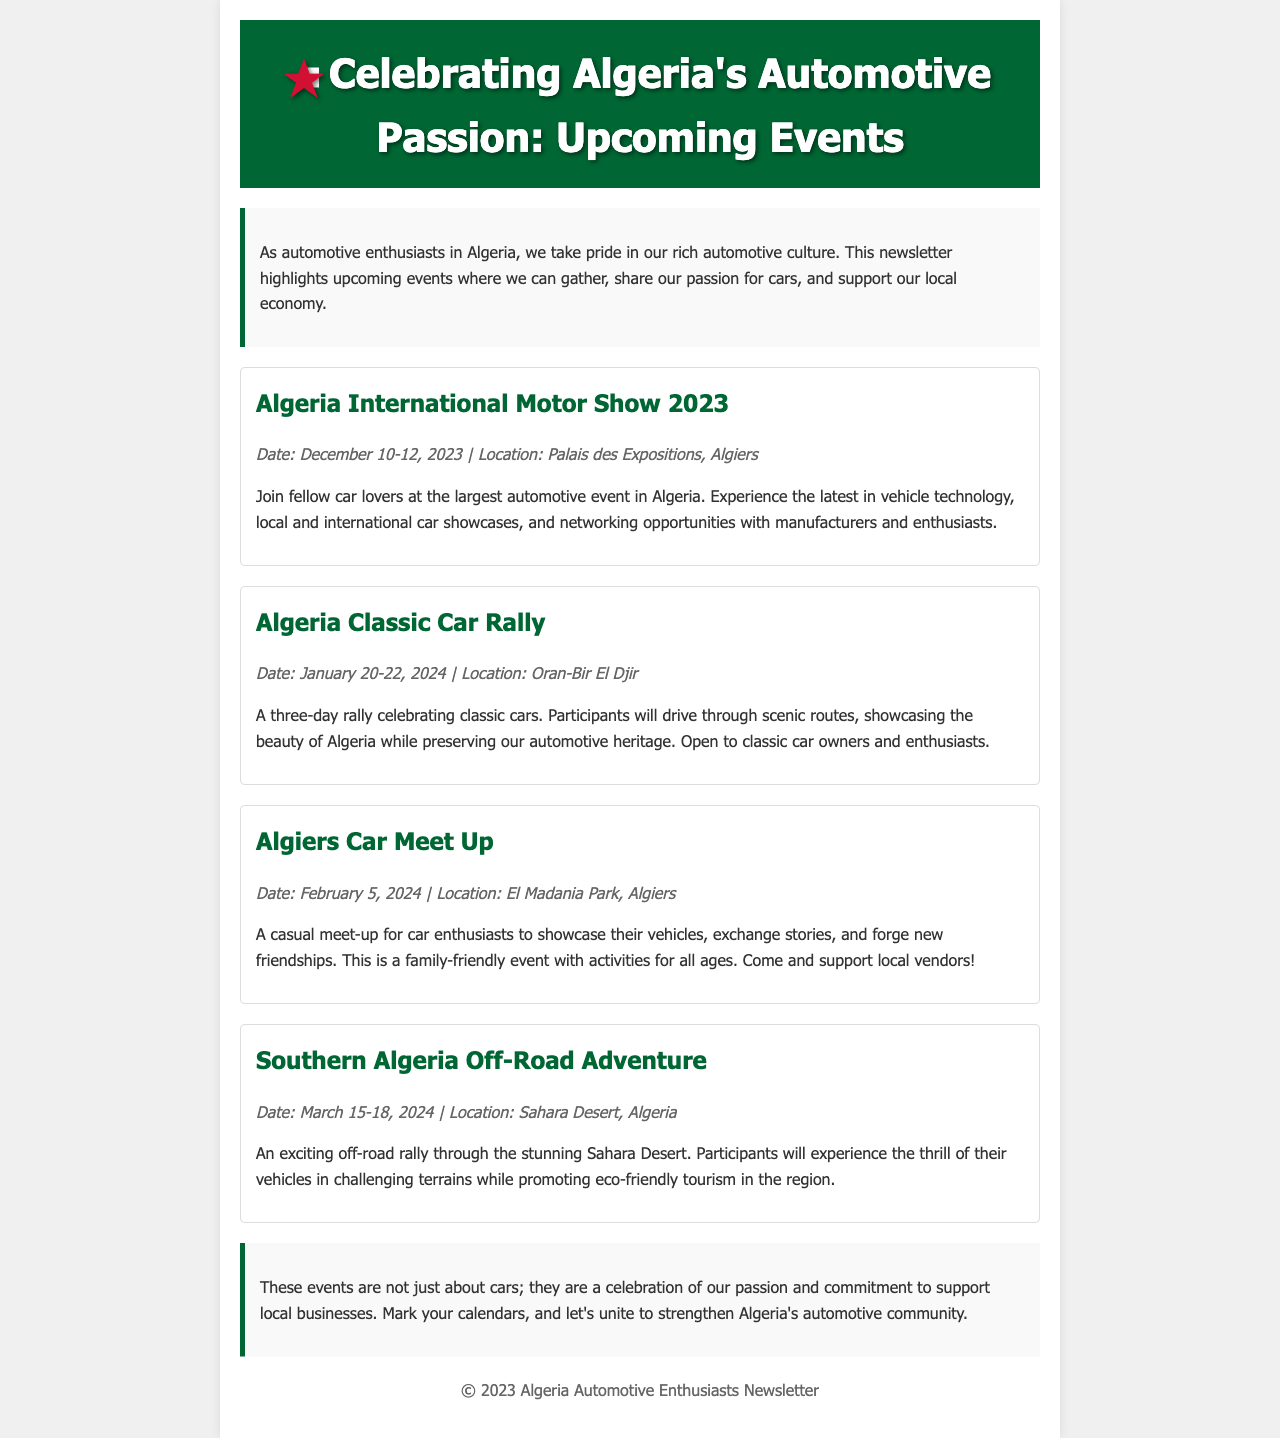What is the date of the Algeria International Motor Show 2023? The event takes place from December 10 to 12, 2023.
Answer: December 10-12, 2023 Where is the Algeria Classic Car Rally located? The rally is held in Oran-Bir El Djir.
Answer: Oran-Bir El Djir What is the starting date of the Algiers Car Meet Up? The meet-up begins on February 5, 2024.
Answer: February 5, 2024 How long will the Southern Algeria Off-Road Adventure last? The event will take place over four days.
Answer: Four days What is the primary focus of the Algiers Car Meet Up? It is a casual meet-up for car enthusiasts.
Answer: Casual meet-up What is one of the goals of the Southern Algeria Off-Road Adventure? It promotes eco-friendly tourism.
Answer: Promote eco-friendly tourism What type of event is the Algeria International Motor Show 2023? It is the largest automotive event in Algeria.
Answer: Largest automotive event What is emphasized in the conclusion of the newsletter? The celebration of passion and commitment to support local businesses.
Answer: Support local businesses 